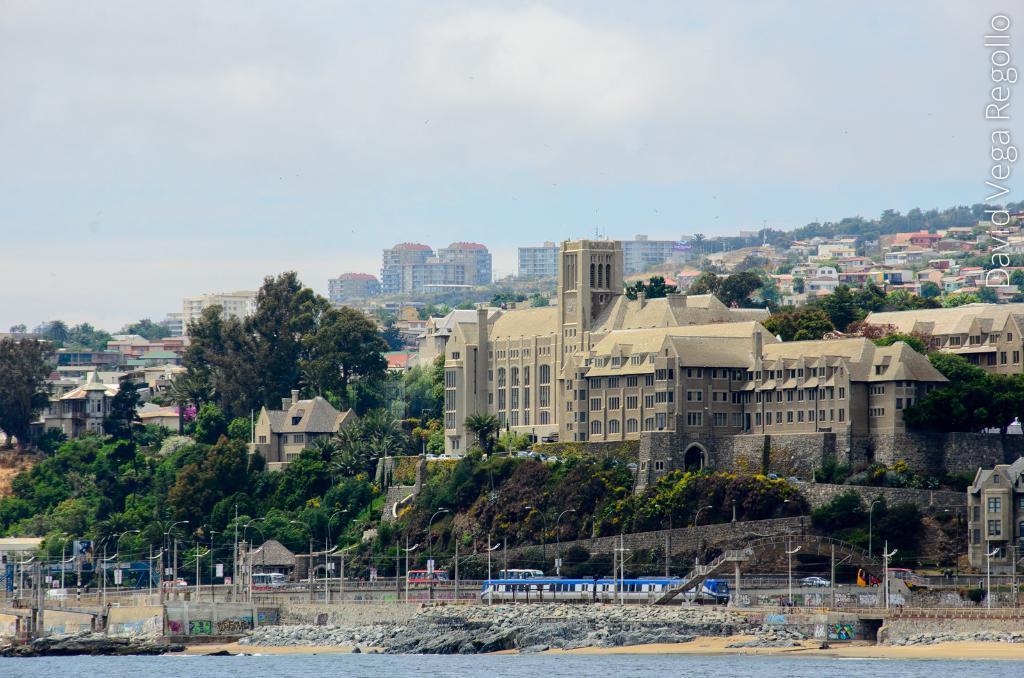Could you give a brief overview of what you see in this image? In this image I can see the water. I can see the vehicles on the road. In the background, I can see the trees, buildings and clouds in the sky. 